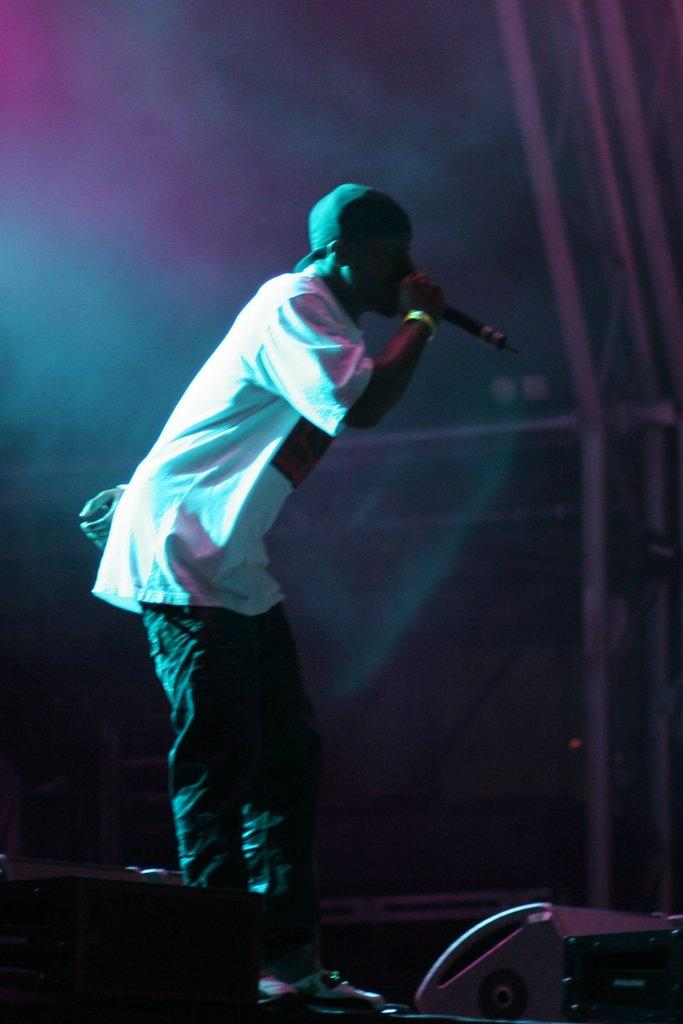Who or what is the main subject in the image? There is a person in the image. What is the person wearing on their head? The person is wearing a hat. What is the person's posture in the image? The person is standing. What object is the person holding in the image? The person is holding a microphone. What other object related to sound can be seen in the image? There is a speaker in the image. Can you see a duck swimming in the image? There is no duck present in the image. What type of needle is being used to connect the microphone and speaker in the image? There is no needle mentioned or visible in the image; the microphone and speaker are not connected in the image. 